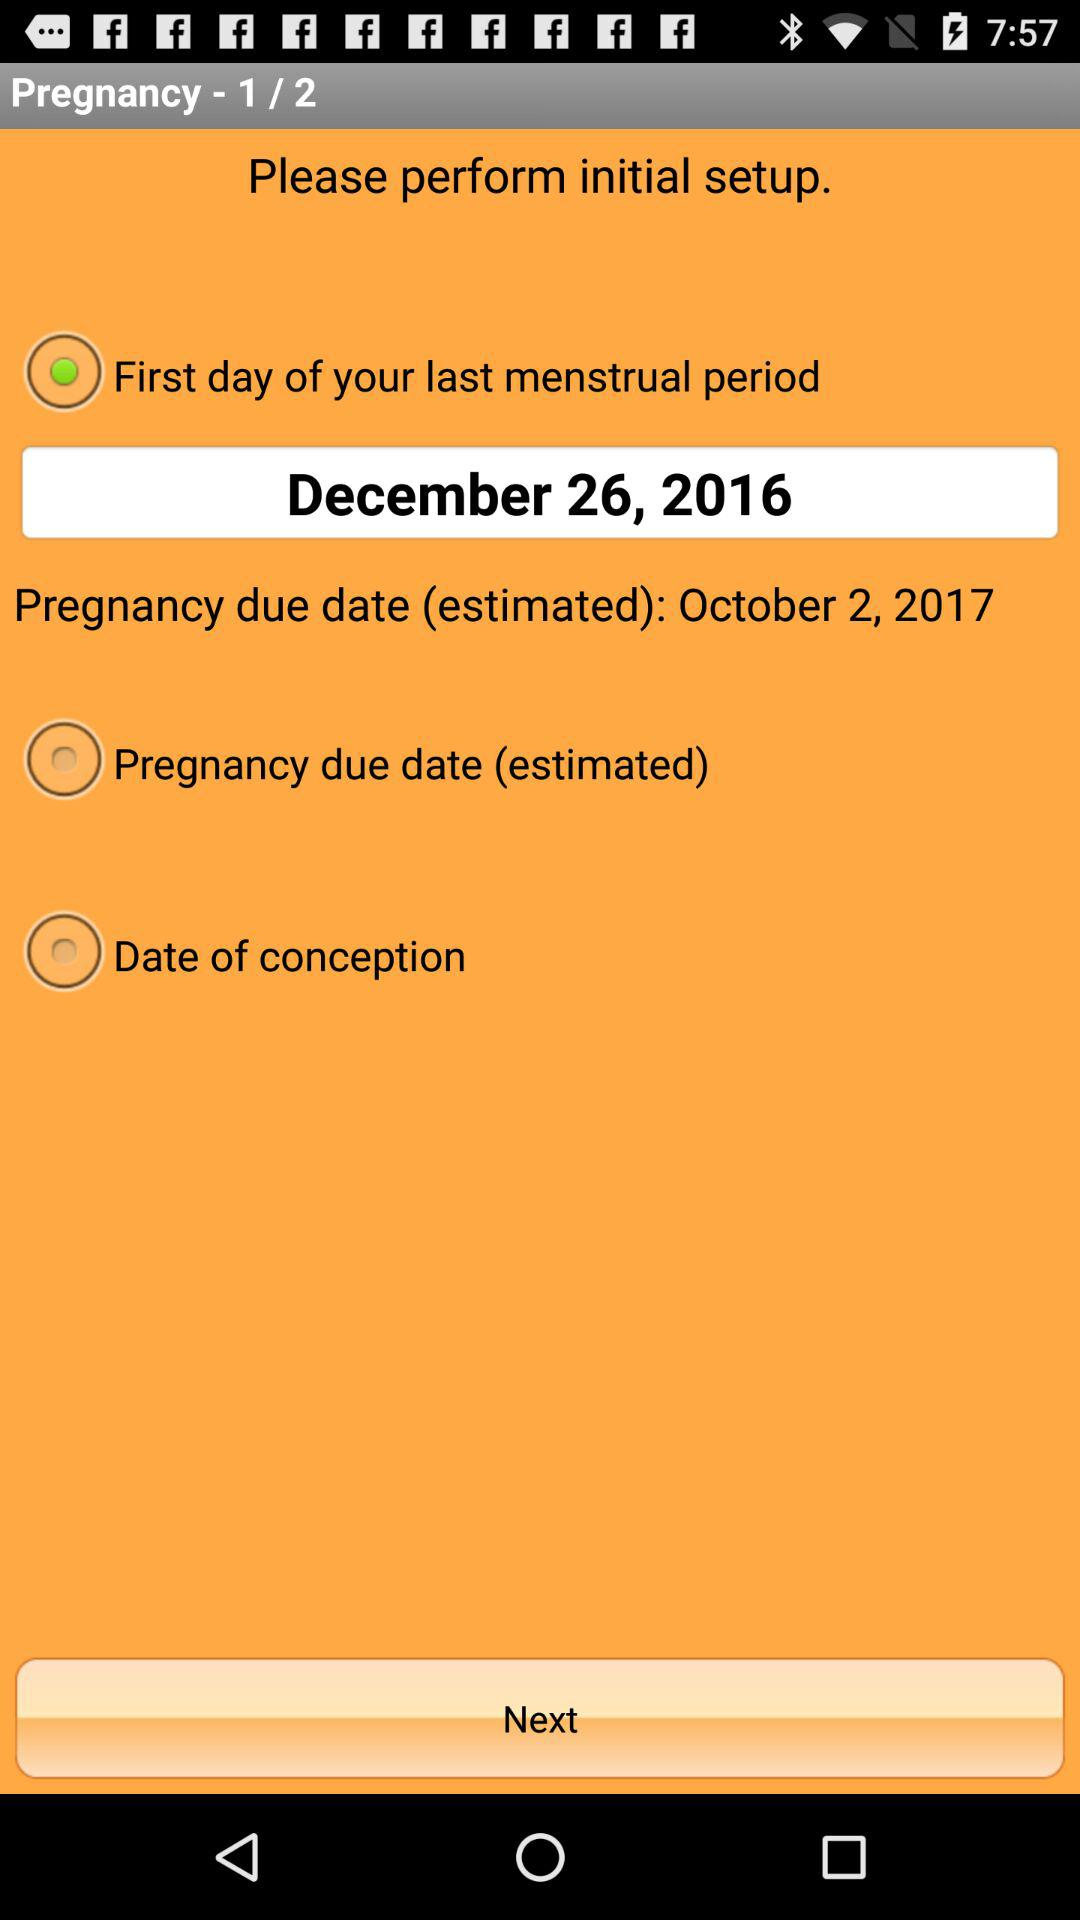What is the date of the first day of the last menstrual period? The date of the first day of the last menstrual period is December 26, 2016. 